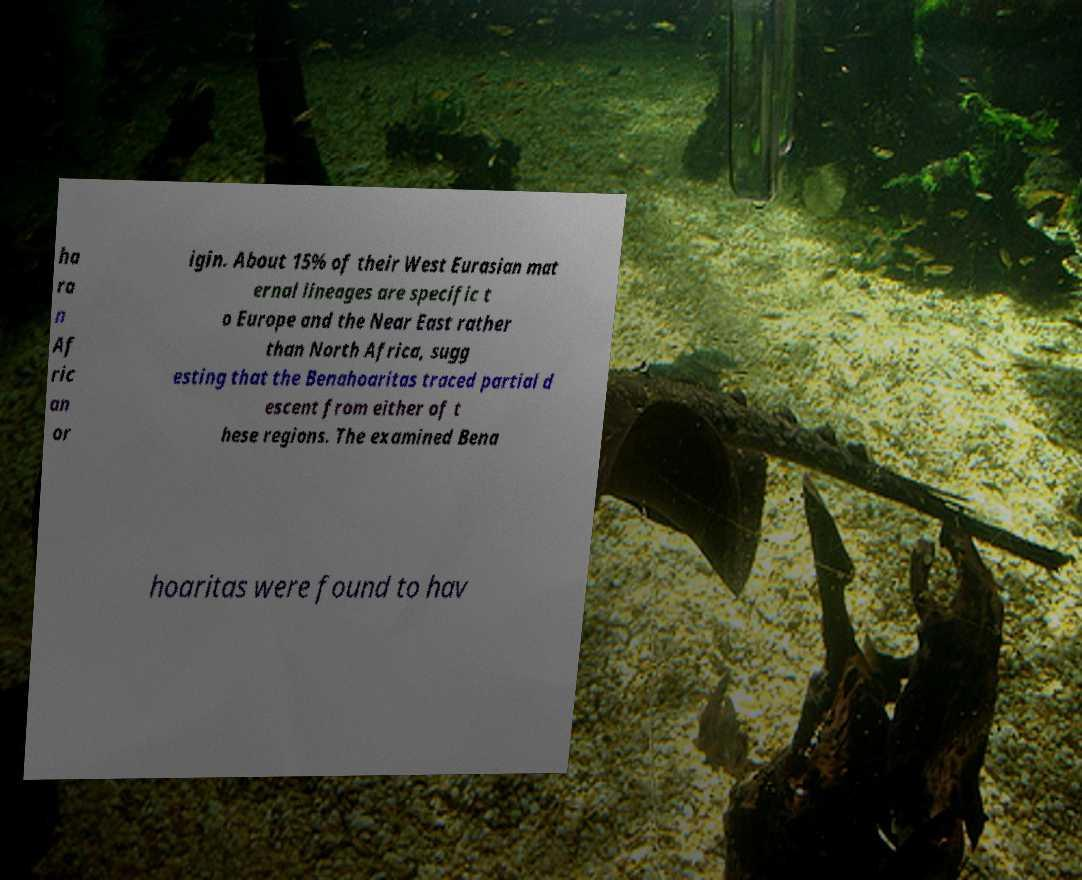What messages or text are displayed in this image? I need them in a readable, typed format. ha ra n Af ric an or igin. About 15% of their West Eurasian mat ernal lineages are specific t o Europe and the Near East rather than North Africa, sugg esting that the Benahoaritas traced partial d escent from either of t hese regions. The examined Bena hoaritas were found to hav 